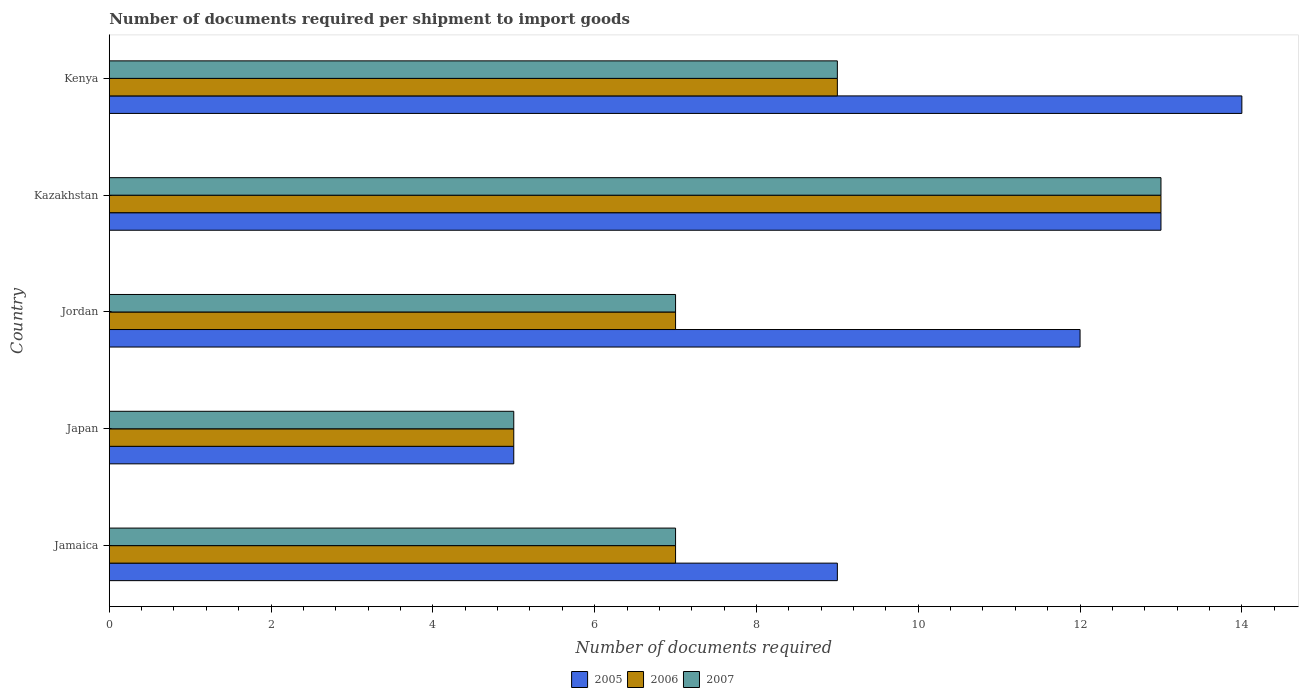How many bars are there on the 2nd tick from the top?
Ensure brevity in your answer.  3. What is the label of the 2nd group of bars from the top?
Make the answer very short. Kazakhstan. In how many cases, is the number of bars for a given country not equal to the number of legend labels?
Your response must be concise. 0. Across all countries, what is the maximum number of documents required per shipment to import goods in 2005?
Your response must be concise. 14. In which country was the number of documents required per shipment to import goods in 2006 maximum?
Provide a short and direct response. Kazakhstan. What is the difference between the number of documents required per shipment to import goods in 2006 in Kazakhstan and that in Kenya?
Give a very brief answer. 4. What is the difference between the number of documents required per shipment to import goods in 2006 in Jordan and the number of documents required per shipment to import goods in 2007 in Kenya?
Offer a very short reply. -2. What is the ratio of the number of documents required per shipment to import goods in 2006 in Jamaica to that in Kenya?
Your answer should be very brief. 0.78. Is the difference between the number of documents required per shipment to import goods in 2005 in Kazakhstan and Kenya greater than the difference between the number of documents required per shipment to import goods in 2006 in Kazakhstan and Kenya?
Ensure brevity in your answer.  No. What is the difference between the highest and the second highest number of documents required per shipment to import goods in 2005?
Your answer should be very brief. 1. What does the 1st bar from the bottom in Japan represents?
Provide a succinct answer. 2005. Is it the case that in every country, the sum of the number of documents required per shipment to import goods in 2006 and number of documents required per shipment to import goods in 2007 is greater than the number of documents required per shipment to import goods in 2005?
Your answer should be compact. Yes. How many bars are there?
Make the answer very short. 15. How many countries are there in the graph?
Your answer should be very brief. 5. What is the difference between two consecutive major ticks on the X-axis?
Provide a short and direct response. 2. Are the values on the major ticks of X-axis written in scientific E-notation?
Ensure brevity in your answer.  No. Does the graph contain any zero values?
Your response must be concise. No. Where does the legend appear in the graph?
Give a very brief answer. Bottom center. How many legend labels are there?
Your answer should be very brief. 3. What is the title of the graph?
Your answer should be compact. Number of documents required per shipment to import goods. Does "1975" appear as one of the legend labels in the graph?
Offer a very short reply. No. What is the label or title of the X-axis?
Ensure brevity in your answer.  Number of documents required. What is the Number of documents required in 2005 in Jamaica?
Keep it short and to the point. 9. What is the Number of documents required of 2005 in Japan?
Offer a terse response. 5. What is the Number of documents required of 2006 in Japan?
Your response must be concise. 5. What is the Number of documents required of 2007 in Jordan?
Your response must be concise. 7. What is the Number of documents required in 2005 in Kazakhstan?
Offer a very short reply. 13. What is the Number of documents required in 2006 in Kazakhstan?
Provide a succinct answer. 13. What is the Number of documents required in 2006 in Kenya?
Ensure brevity in your answer.  9. Across all countries, what is the maximum Number of documents required of 2006?
Provide a short and direct response. 13. Across all countries, what is the minimum Number of documents required in 2005?
Offer a terse response. 5. Across all countries, what is the minimum Number of documents required in 2006?
Your response must be concise. 5. What is the total Number of documents required of 2005 in the graph?
Provide a short and direct response. 53. What is the difference between the Number of documents required of 2006 in Jamaica and that in Jordan?
Offer a very short reply. 0. What is the difference between the Number of documents required in 2007 in Jamaica and that in Jordan?
Provide a succinct answer. 0. What is the difference between the Number of documents required of 2005 in Jamaica and that in Kenya?
Give a very brief answer. -5. What is the difference between the Number of documents required of 2006 in Jamaica and that in Kenya?
Provide a short and direct response. -2. What is the difference between the Number of documents required of 2005 in Japan and that in Jordan?
Provide a succinct answer. -7. What is the difference between the Number of documents required in 2006 in Japan and that in Jordan?
Provide a short and direct response. -2. What is the difference between the Number of documents required in 2007 in Japan and that in Jordan?
Ensure brevity in your answer.  -2. What is the difference between the Number of documents required in 2005 in Japan and that in Kazakhstan?
Your answer should be compact. -8. What is the difference between the Number of documents required of 2006 in Japan and that in Kazakhstan?
Give a very brief answer. -8. What is the difference between the Number of documents required in 2006 in Japan and that in Kenya?
Give a very brief answer. -4. What is the difference between the Number of documents required of 2005 in Jordan and that in Kazakhstan?
Your answer should be compact. -1. What is the difference between the Number of documents required of 2005 in Jordan and that in Kenya?
Your answer should be very brief. -2. What is the difference between the Number of documents required of 2006 in Kazakhstan and that in Kenya?
Make the answer very short. 4. What is the difference between the Number of documents required in 2005 in Jamaica and the Number of documents required in 2006 in Japan?
Your response must be concise. 4. What is the difference between the Number of documents required in 2005 in Jamaica and the Number of documents required in 2007 in Japan?
Keep it short and to the point. 4. What is the difference between the Number of documents required in 2006 in Jamaica and the Number of documents required in 2007 in Japan?
Keep it short and to the point. 2. What is the difference between the Number of documents required in 2005 in Jamaica and the Number of documents required in 2007 in Jordan?
Make the answer very short. 2. What is the difference between the Number of documents required in 2005 in Jamaica and the Number of documents required in 2006 in Kazakhstan?
Make the answer very short. -4. What is the difference between the Number of documents required of 2005 in Jamaica and the Number of documents required of 2007 in Kazakhstan?
Give a very brief answer. -4. What is the difference between the Number of documents required in 2006 in Jamaica and the Number of documents required in 2007 in Kazakhstan?
Offer a terse response. -6. What is the difference between the Number of documents required in 2005 in Jamaica and the Number of documents required in 2007 in Kenya?
Make the answer very short. 0. What is the difference between the Number of documents required of 2005 in Japan and the Number of documents required of 2006 in Jordan?
Offer a very short reply. -2. What is the difference between the Number of documents required in 2005 in Japan and the Number of documents required in 2007 in Jordan?
Your answer should be very brief. -2. What is the difference between the Number of documents required in 2006 in Japan and the Number of documents required in 2007 in Jordan?
Keep it short and to the point. -2. What is the difference between the Number of documents required of 2005 in Japan and the Number of documents required of 2006 in Kazakhstan?
Offer a terse response. -8. What is the difference between the Number of documents required of 2005 in Japan and the Number of documents required of 2007 in Kenya?
Offer a terse response. -4. What is the difference between the Number of documents required in 2005 in Jordan and the Number of documents required in 2006 in Kazakhstan?
Provide a succinct answer. -1. What is the difference between the Number of documents required in 2005 in Jordan and the Number of documents required in 2007 in Kazakhstan?
Offer a very short reply. -1. What is the difference between the Number of documents required of 2006 in Jordan and the Number of documents required of 2007 in Kazakhstan?
Offer a very short reply. -6. What is the difference between the Number of documents required in 2005 in Jordan and the Number of documents required in 2007 in Kenya?
Provide a short and direct response. 3. What is the difference between the Number of documents required in 2006 in Jordan and the Number of documents required in 2007 in Kenya?
Offer a terse response. -2. What is the difference between the Number of documents required in 2005 in Kazakhstan and the Number of documents required in 2006 in Kenya?
Your response must be concise. 4. What is the difference between the Number of documents required of 2005 in Kazakhstan and the Number of documents required of 2007 in Kenya?
Make the answer very short. 4. What is the average Number of documents required of 2005 per country?
Ensure brevity in your answer.  10.6. What is the difference between the Number of documents required of 2005 and Number of documents required of 2006 in Jamaica?
Ensure brevity in your answer.  2. What is the difference between the Number of documents required of 2006 and Number of documents required of 2007 in Japan?
Make the answer very short. 0. What is the difference between the Number of documents required in 2005 and Number of documents required in 2006 in Jordan?
Keep it short and to the point. 5. What is the difference between the Number of documents required of 2006 and Number of documents required of 2007 in Jordan?
Your response must be concise. 0. What is the difference between the Number of documents required of 2005 and Number of documents required of 2006 in Kazakhstan?
Your answer should be compact. 0. What is the difference between the Number of documents required in 2006 and Number of documents required in 2007 in Kazakhstan?
Your answer should be very brief. 0. What is the difference between the Number of documents required of 2005 and Number of documents required of 2006 in Kenya?
Make the answer very short. 5. What is the difference between the Number of documents required in 2005 and Number of documents required in 2007 in Kenya?
Provide a succinct answer. 5. What is the ratio of the Number of documents required in 2005 in Jamaica to that in Jordan?
Give a very brief answer. 0.75. What is the ratio of the Number of documents required of 2006 in Jamaica to that in Jordan?
Make the answer very short. 1. What is the ratio of the Number of documents required in 2007 in Jamaica to that in Jordan?
Your answer should be very brief. 1. What is the ratio of the Number of documents required in 2005 in Jamaica to that in Kazakhstan?
Keep it short and to the point. 0.69. What is the ratio of the Number of documents required in 2006 in Jamaica to that in Kazakhstan?
Your answer should be very brief. 0.54. What is the ratio of the Number of documents required of 2007 in Jamaica to that in Kazakhstan?
Provide a short and direct response. 0.54. What is the ratio of the Number of documents required of 2005 in Jamaica to that in Kenya?
Provide a succinct answer. 0.64. What is the ratio of the Number of documents required of 2007 in Jamaica to that in Kenya?
Give a very brief answer. 0.78. What is the ratio of the Number of documents required of 2005 in Japan to that in Jordan?
Give a very brief answer. 0.42. What is the ratio of the Number of documents required of 2006 in Japan to that in Jordan?
Your answer should be very brief. 0.71. What is the ratio of the Number of documents required of 2007 in Japan to that in Jordan?
Give a very brief answer. 0.71. What is the ratio of the Number of documents required in 2005 in Japan to that in Kazakhstan?
Your answer should be compact. 0.38. What is the ratio of the Number of documents required of 2006 in Japan to that in Kazakhstan?
Provide a succinct answer. 0.38. What is the ratio of the Number of documents required in 2007 in Japan to that in Kazakhstan?
Ensure brevity in your answer.  0.38. What is the ratio of the Number of documents required of 2005 in Japan to that in Kenya?
Your answer should be compact. 0.36. What is the ratio of the Number of documents required in 2006 in Japan to that in Kenya?
Your answer should be compact. 0.56. What is the ratio of the Number of documents required of 2007 in Japan to that in Kenya?
Provide a succinct answer. 0.56. What is the ratio of the Number of documents required of 2006 in Jordan to that in Kazakhstan?
Your answer should be compact. 0.54. What is the ratio of the Number of documents required of 2007 in Jordan to that in Kazakhstan?
Make the answer very short. 0.54. What is the ratio of the Number of documents required of 2006 in Jordan to that in Kenya?
Ensure brevity in your answer.  0.78. What is the ratio of the Number of documents required of 2005 in Kazakhstan to that in Kenya?
Your answer should be compact. 0.93. What is the ratio of the Number of documents required of 2006 in Kazakhstan to that in Kenya?
Keep it short and to the point. 1.44. What is the ratio of the Number of documents required of 2007 in Kazakhstan to that in Kenya?
Offer a very short reply. 1.44. What is the difference between the highest and the second highest Number of documents required in 2005?
Keep it short and to the point. 1. What is the difference between the highest and the second highest Number of documents required in 2007?
Offer a terse response. 4. What is the difference between the highest and the lowest Number of documents required in 2006?
Your answer should be compact. 8. What is the difference between the highest and the lowest Number of documents required of 2007?
Keep it short and to the point. 8. 